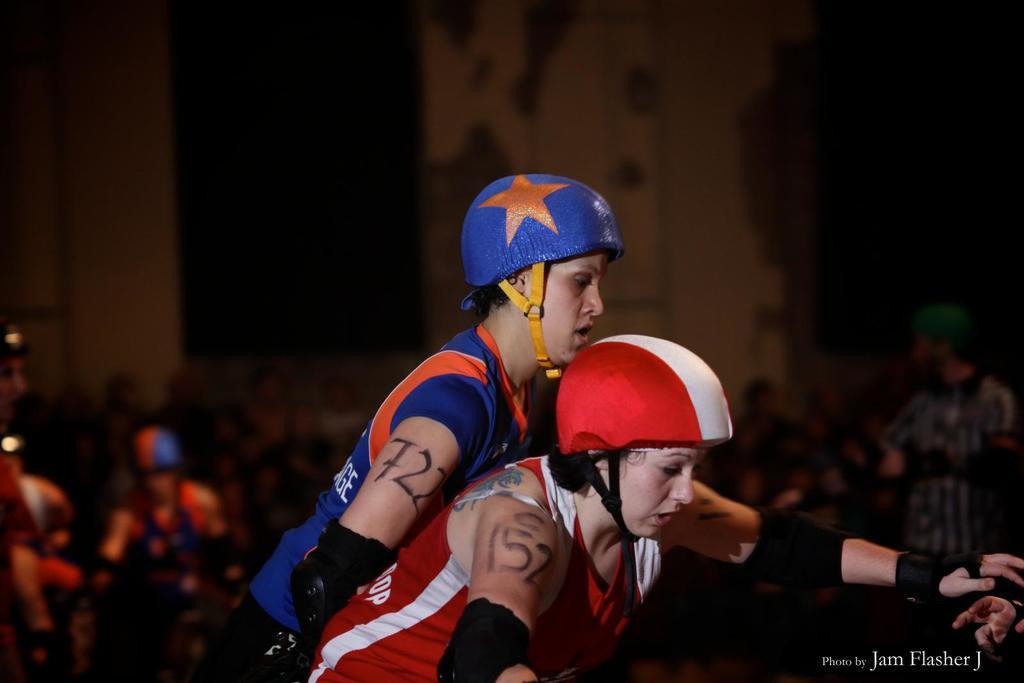Please provide a concise description of this image. This picture shows couple of women. They wore helmets on their head and we see a building and a man standing and few are seated. 